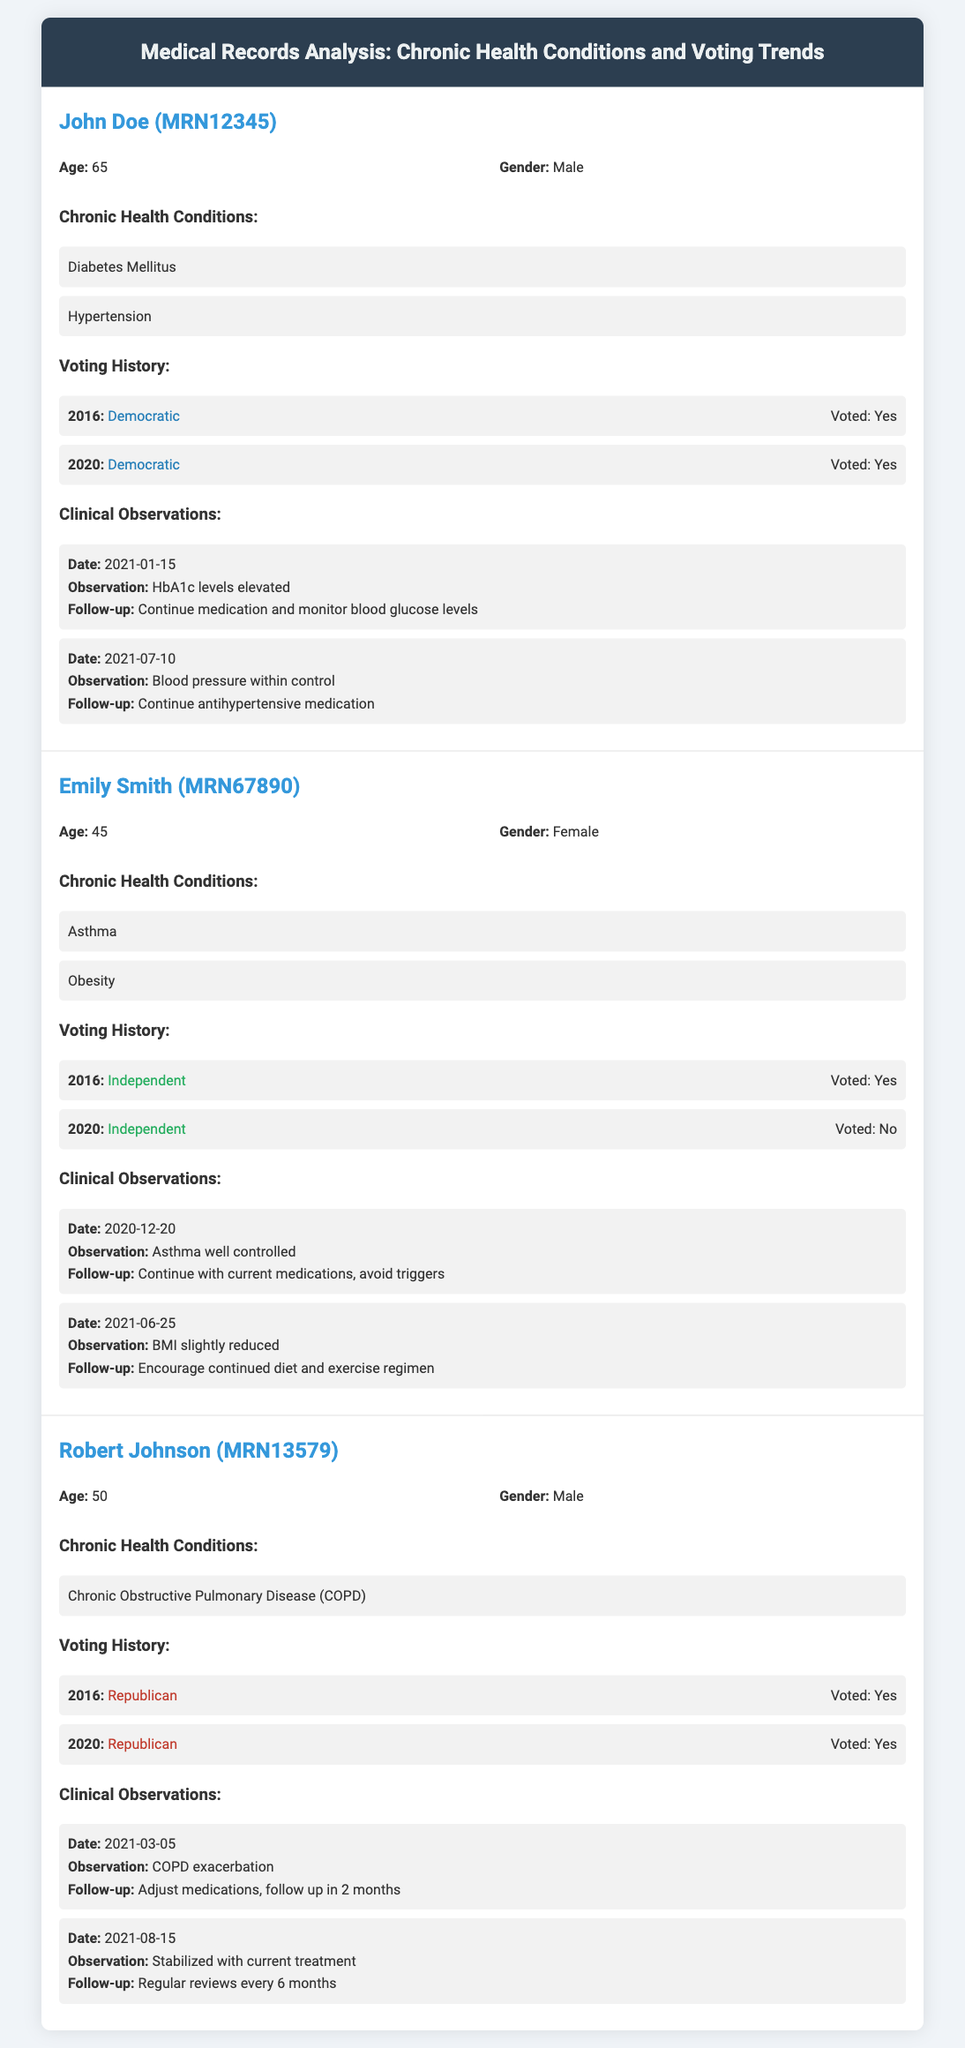What is John Doe's age? The document states John Doe's age is provided under the patient information section.
Answer: 65 What chronic health condition does Emily Smith have? The document lists Emily Smith's chronic health conditions, which include Asthma and Obesity.
Answer: Asthma Which party did Robert Johnson vote for in 2016? Robert Johnson's voting history shows his party affiliation for the 2016 election.
Answer: Republican How many times did John Doe vote in total? The voting history for John Doe indicates the number of elections he participated in.
Answer: 2 What was the observation date for Emily Smith's well-controlled asthma? The document lists specific dates for clinical observations of Emily Smith, including when her asthma was reported as well controlled.
Answer: 2020-12-20 What chronic health condition is associated with Robert Johnson? The document identifies Robert Johnson's chronic health condition listed under his records.
Answer: Chronic Obstructive Pulmonary Disease (COPD) What follow-up was recommended for John Doe's elevated HbA1c levels? The clinical observation details indicate the follow-up plan for John Doe's health condition.
Answer: Continue medication and monitor blood glucose levels Did Emily Smith vote in the 2020 election? The voting history section shows whether Emily Smith participated in the 2020 election.
Answer: No How many chronic health conditions does John Doe have? The document specifies the number of chronic health conditions listed under John Doe's profile.
Answer: 2 